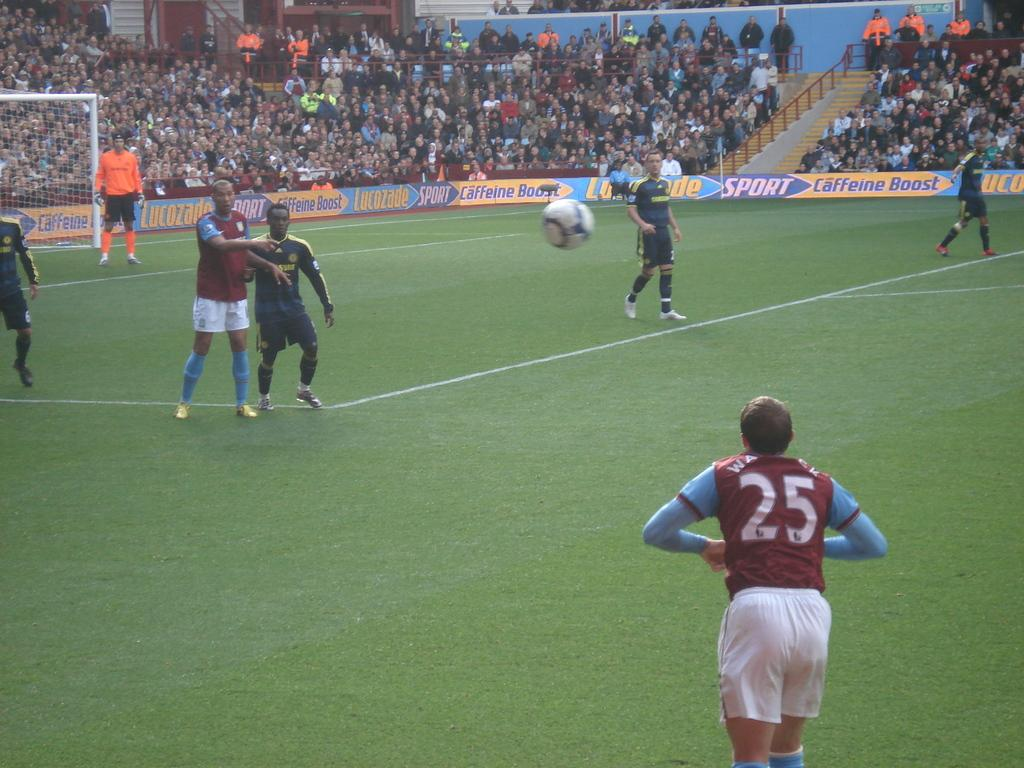<image>
Offer a succinct explanation of the picture presented. Player number 25 throws a soccer ball into the field of play. 